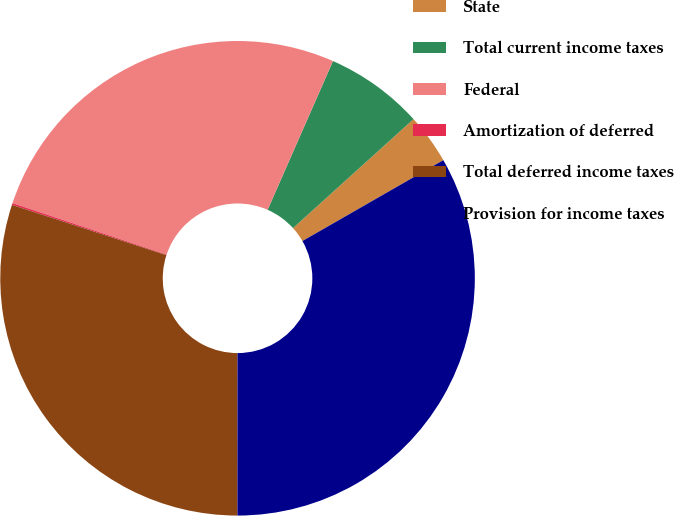Convert chart. <chart><loc_0><loc_0><loc_500><loc_500><pie_chart><fcel>State<fcel>Total current income taxes<fcel>Federal<fcel>Amortization of deferred<fcel>Total deferred income taxes<fcel>Provision for income taxes<nl><fcel>3.41%<fcel>6.71%<fcel>26.46%<fcel>0.12%<fcel>30.0%<fcel>33.3%<nl></chart> 